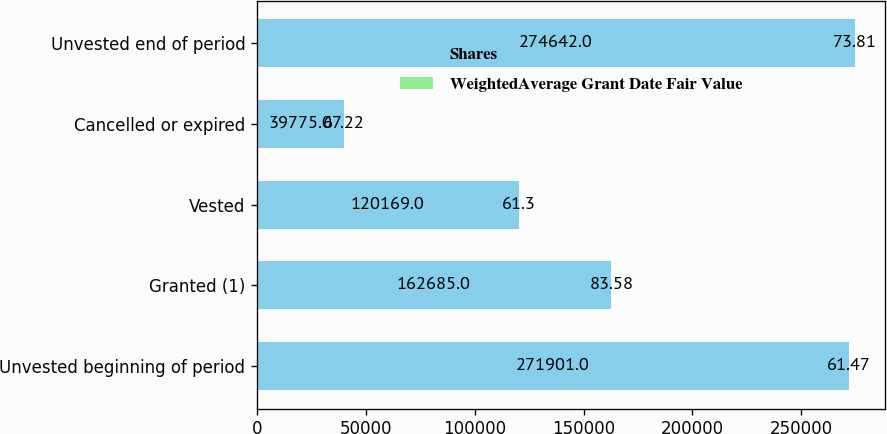Convert chart to OTSL. <chart><loc_0><loc_0><loc_500><loc_500><stacked_bar_chart><ecel><fcel>Unvested beginning of period<fcel>Granted (1)<fcel>Vested<fcel>Cancelled or expired<fcel>Unvested end of period<nl><fcel>Shares<fcel>271901<fcel>162685<fcel>120169<fcel>39775<fcel>274642<nl><fcel>WeightedAverage Grant Date Fair Value<fcel>61.47<fcel>83.58<fcel>61.3<fcel>67.22<fcel>73.81<nl></chart> 